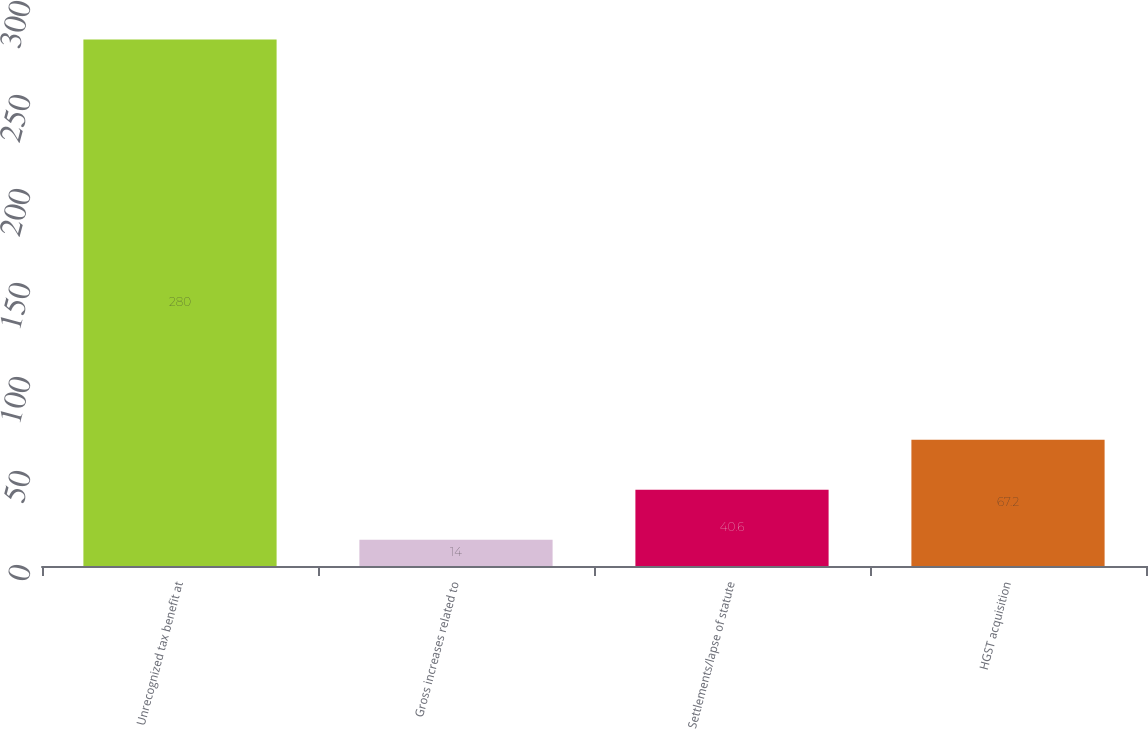Convert chart to OTSL. <chart><loc_0><loc_0><loc_500><loc_500><bar_chart><fcel>Unrecognized tax benefit at<fcel>Gross increases related to<fcel>Settlements/lapse of statute<fcel>HGST acquisition<nl><fcel>280<fcel>14<fcel>40.6<fcel>67.2<nl></chart> 